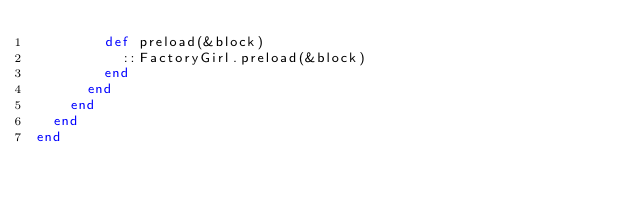Convert code to text. <code><loc_0><loc_0><loc_500><loc_500><_Ruby_>        def preload(&block)
          ::FactoryGirl.preload(&block)
        end
      end
    end
  end
end
</code> 